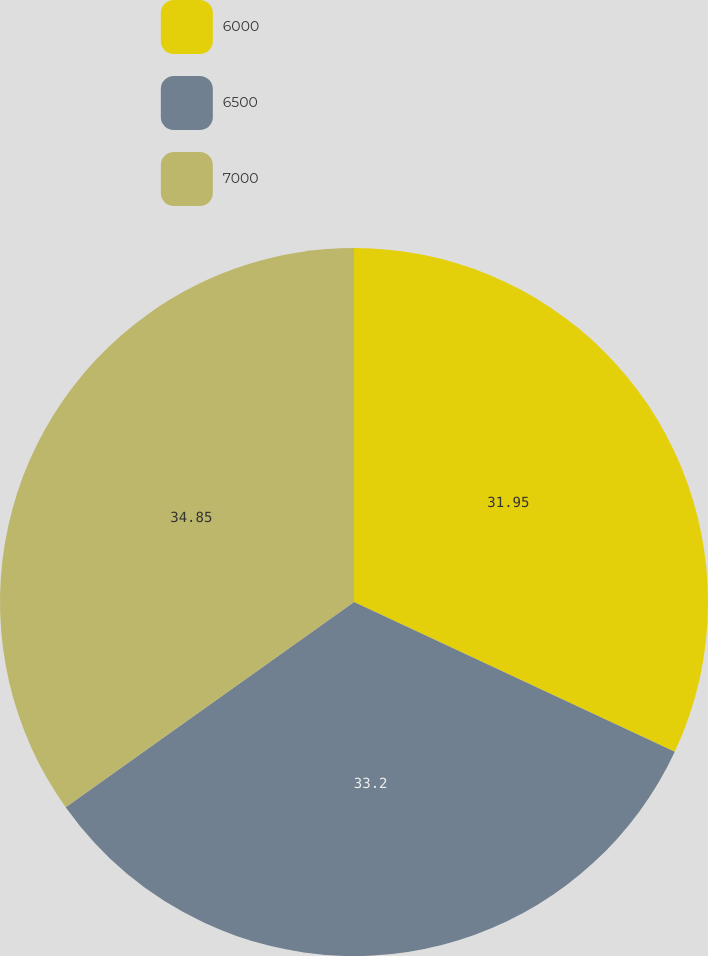<chart> <loc_0><loc_0><loc_500><loc_500><pie_chart><fcel>6000<fcel>6500<fcel>7000<nl><fcel>31.95%<fcel>33.2%<fcel>34.85%<nl></chart> 